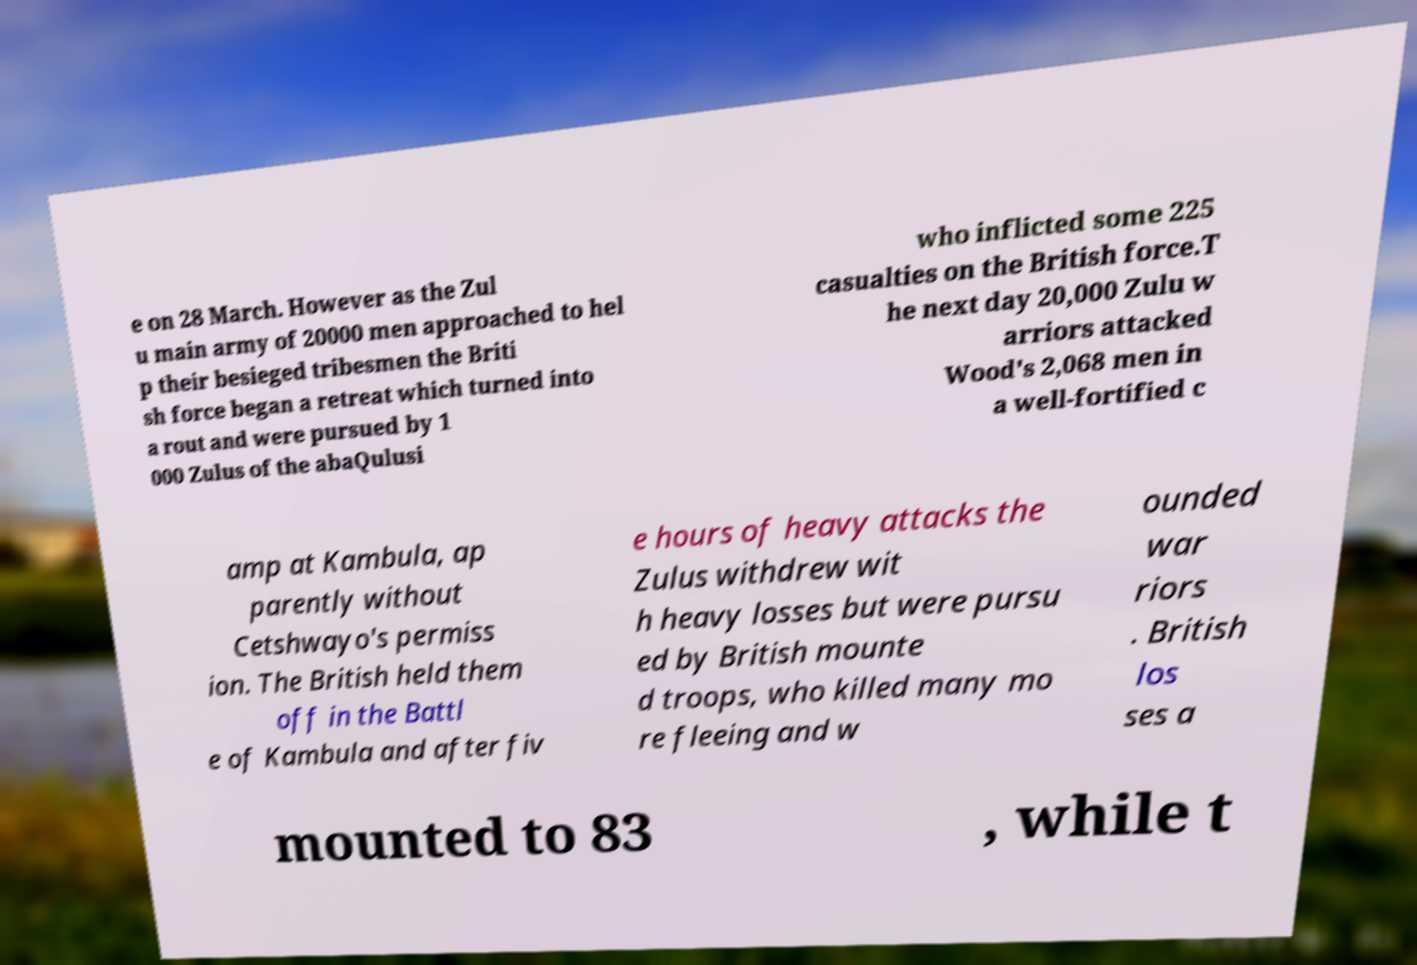There's text embedded in this image that I need extracted. Can you transcribe it verbatim? e on 28 March. However as the Zul u main army of 20000 men approached to hel p their besieged tribesmen the Briti sh force began a retreat which turned into a rout and were pursued by 1 000 Zulus of the abaQulusi who inflicted some 225 casualties on the British force.T he next day 20,000 Zulu w arriors attacked Wood's 2,068 men in a well-fortified c amp at Kambula, ap parently without Cetshwayo's permiss ion. The British held them off in the Battl e of Kambula and after fiv e hours of heavy attacks the Zulus withdrew wit h heavy losses but were pursu ed by British mounte d troops, who killed many mo re fleeing and w ounded war riors . British los ses a mounted to 83 , while t 